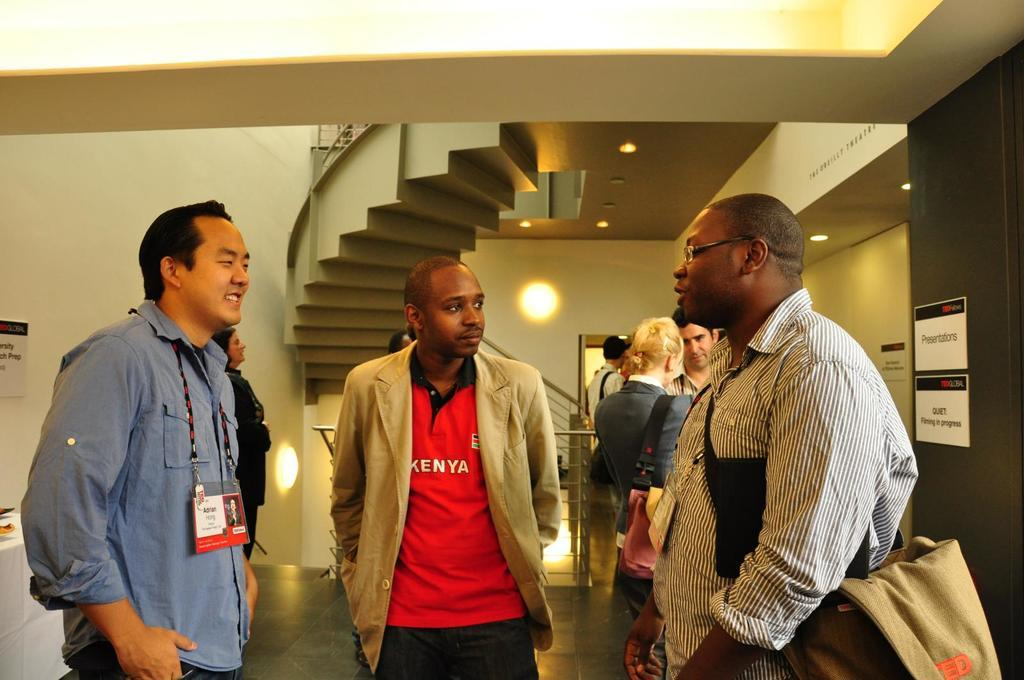How many people are in the image? There is a group of people standing in the image. Where are the people standing? The people are standing on the floor. What can be seen on the walls in the image? There are posters on the walls in the image. What is visible in the background of the image? There are lights and steps visible in the background. Can you describe the toad that is sitting on the steps in the image? There is no toad present in the image; the steps are visible in the background, but no toad is depicted. 